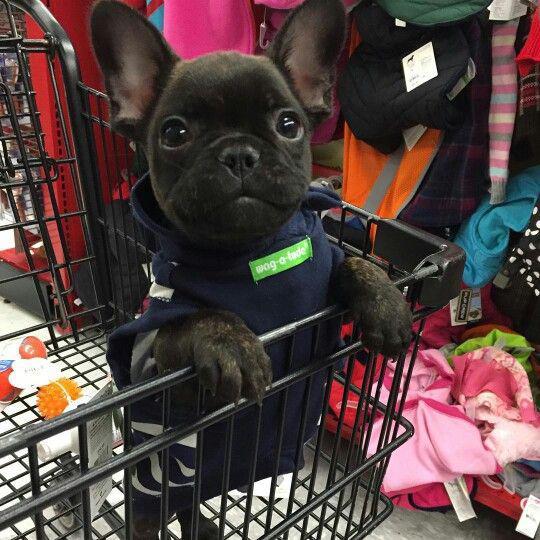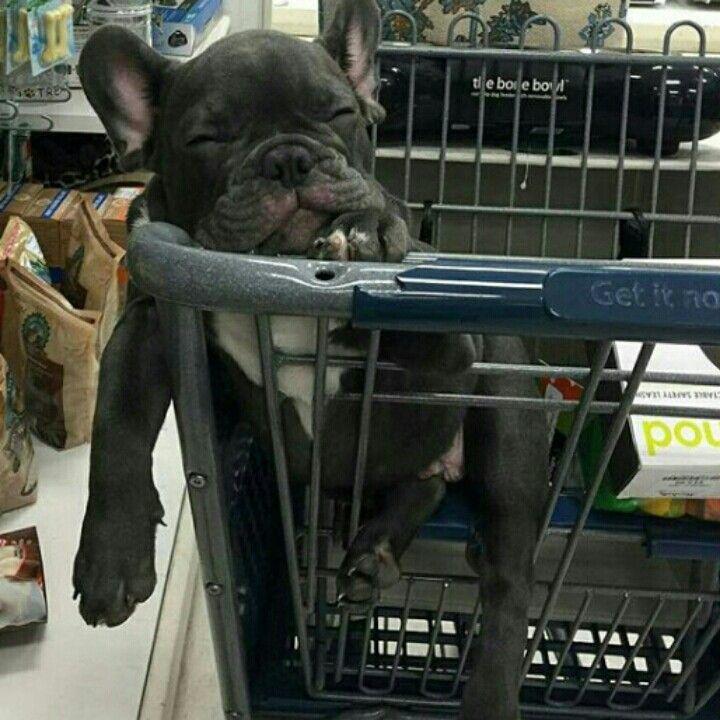The first image is the image on the left, the second image is the image on the right. Examine the images to the left and right. Is the description "Two puppies are inside a shopping cart." accurate? Answer yes or no. Yes. The first image is the image on the left, the second image is the image on the right. Assess this claim about the two images: "A dark dog is wearing a blue vest and is inside of a shopping cart.". Correct or not? Answer yes or no. Yes. 